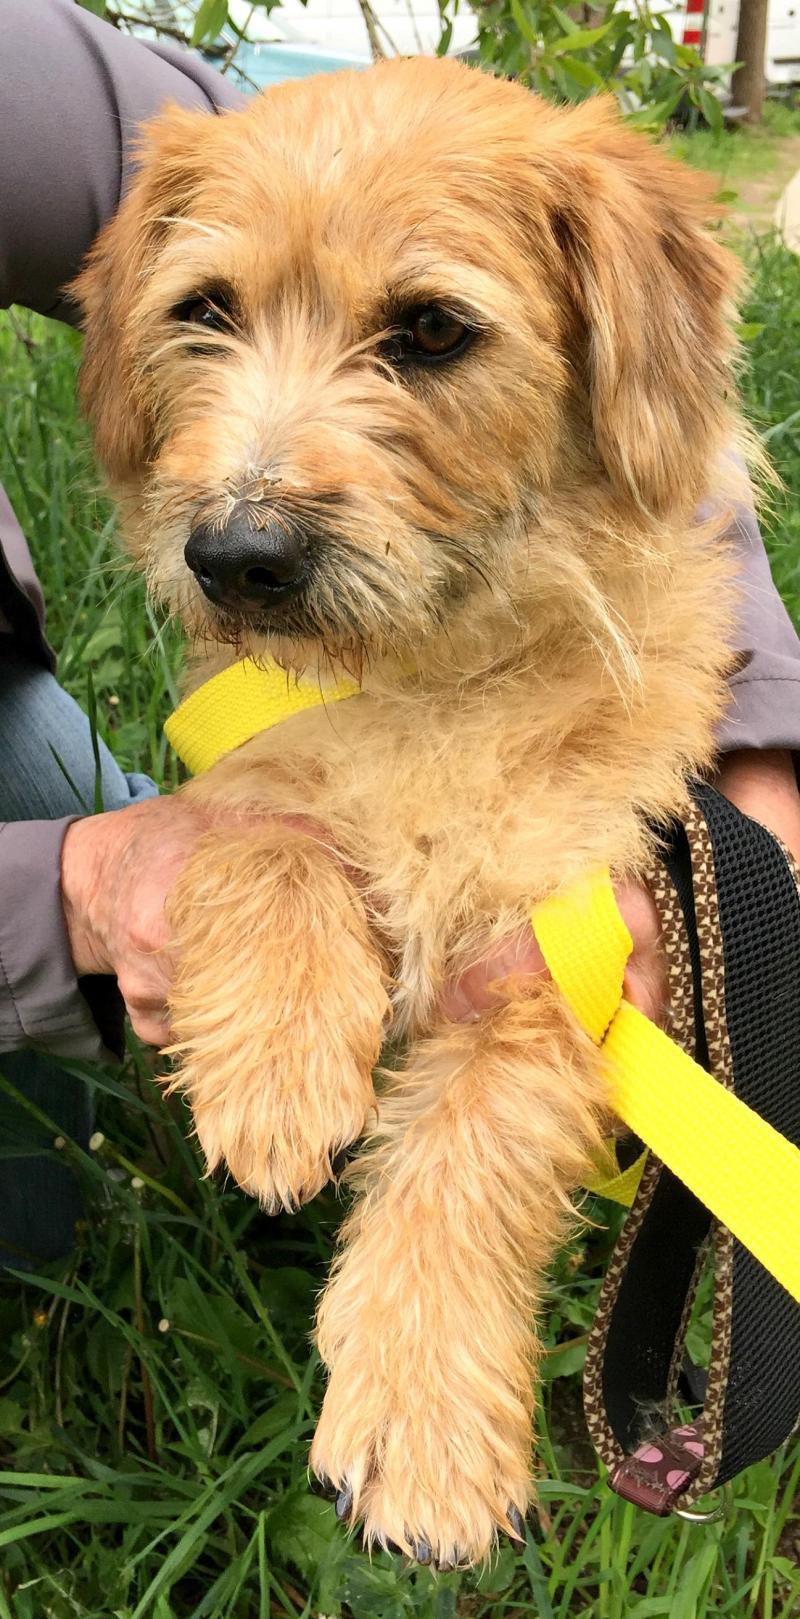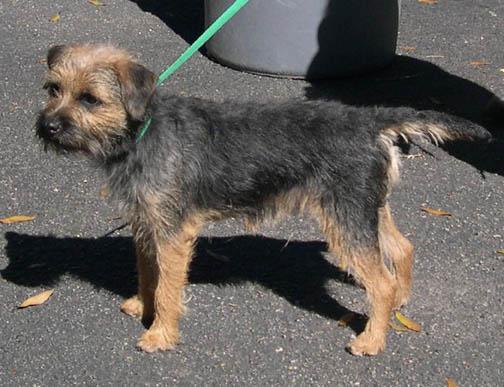The first image is the image on the left, the second image is the image on the right. Evaluate the accuracy of this statement regarding the images: "The dog in the right image has a green leash.". Is it true? Answer yes or no. Yes. The first image is the image on the left, the second image is the image on the right. For the images displayed, is the sentence "A dog is on carpet in one picture and on a blanket in the other picture." factually correct? Answer yes or no. No. 